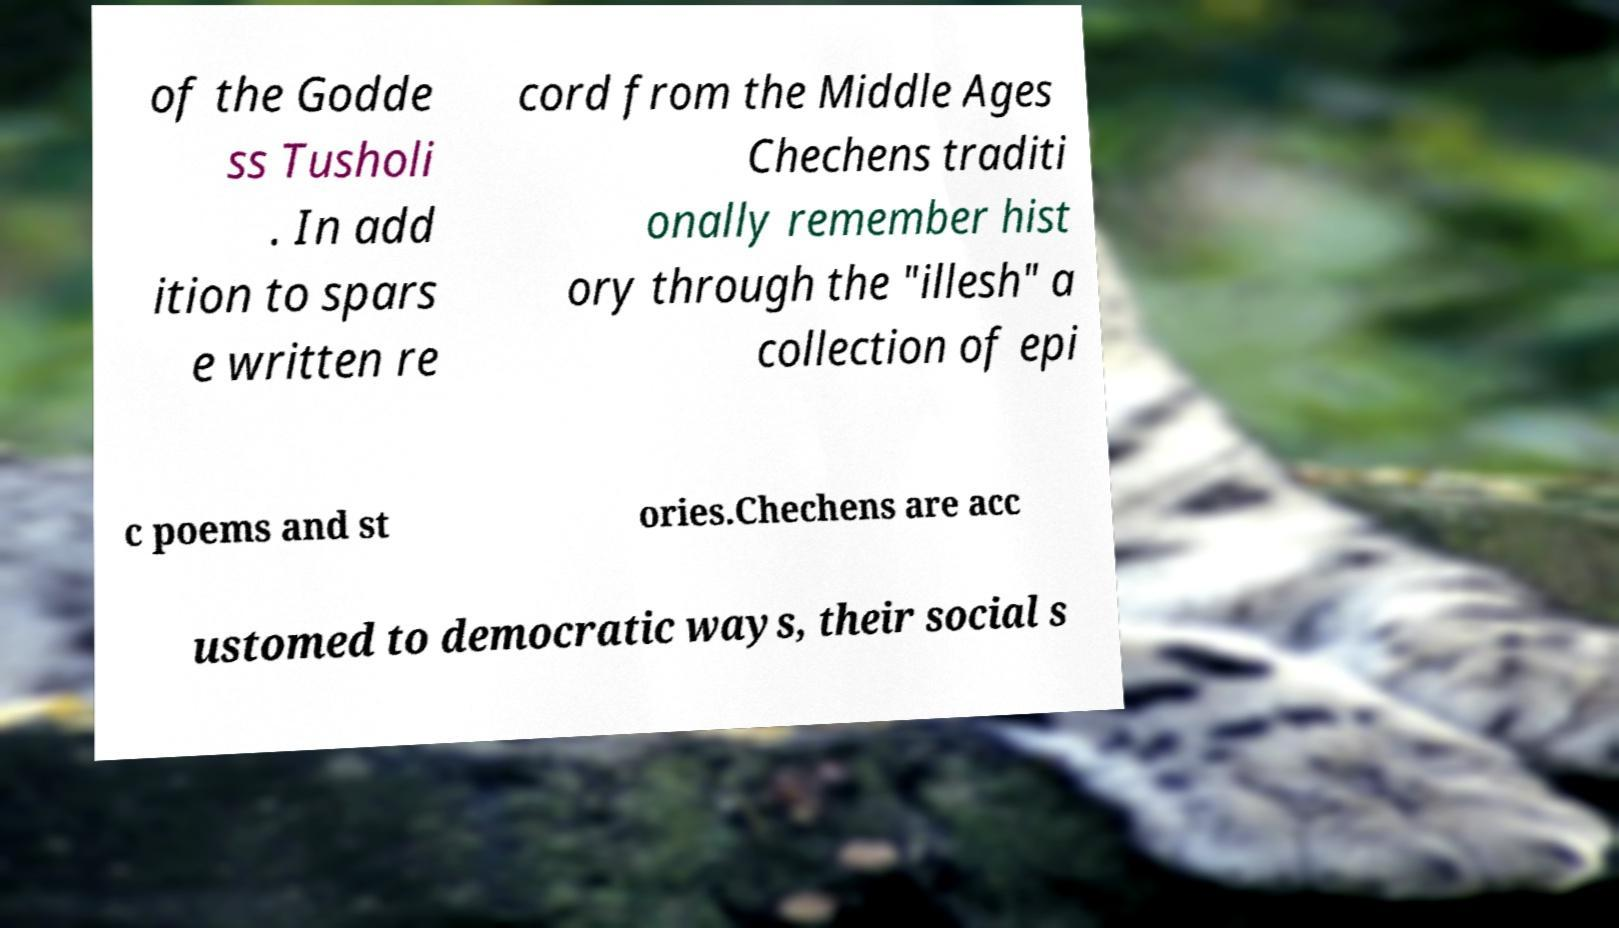Can you read and provide the text displayed in the image?This photo seems to have some interesting text. Can you extract and type it out for me? of the Godde ss Tusholi . In add ition to spars e written re cord from the Middle Ages Chechens traditi onally remember hist ory through the "illesh" a collection of epi c poems and st ories.Chechens are acc ustomed to democratic ways, their social s 